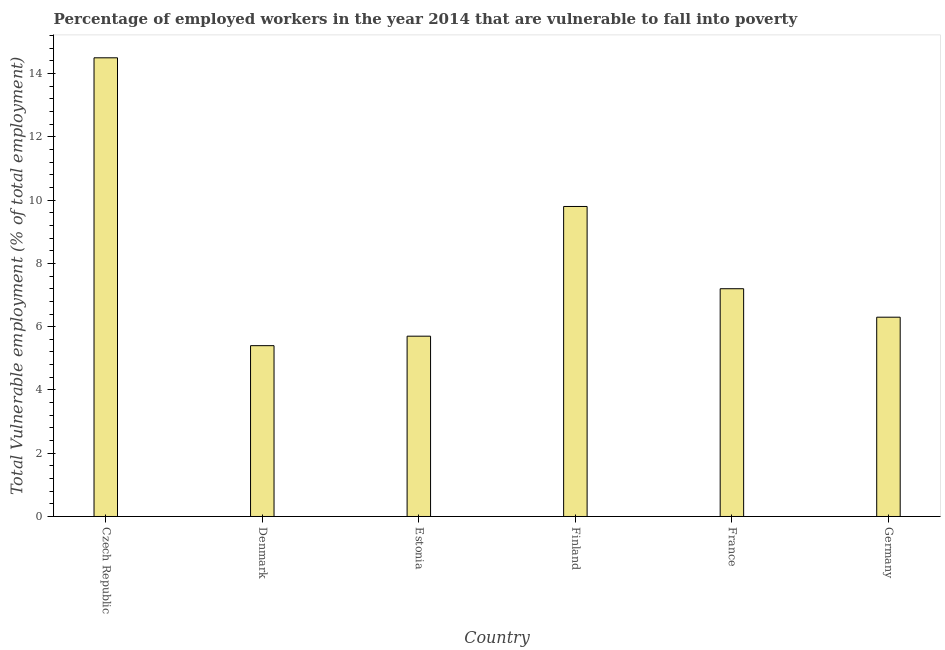Does the graph contain any zero values?
Your answer should be very brief. No. What is the title of the graph?
Your answer should be very brief. Percentage of employed workers in the year 2014 that are vulnerable to fall into poverty. What is the label or title of the X-axis?
Your answer should be compact. Country. What is the label or title of the Y-axis?
Your answer should be compact. Total Vulnerable employment (% of total employment). What is the total vulnerable employment in Denmark?
Keep it short and to the point. 5.4. Across all countries, what is the maximum total vulnerable employment?
Keep it short and to the point. 14.5. Across all countries, what is the minimum total vulnerable employment?
Keep it short and to the point. 5.4. In which country was the total vulnerable employment maximum?
Keep it short and to the point. Czech Republic. What is the sum of the total vulnerable employment?
Your answer should be compact. 48.9. What is the average total vulnerable employment per country?
Offer a very short reply. 8.15. What is the median total vulnerable employment?
Keep it short and to the point. 6.75. In how many countries, is the total vulnerable employment greater than 13.6 %?
Your answer should be very brief. 1. What is the ratio of the total vulnerable employment in Czech Republic to that in Finland?
Your answer should be compact. 1.48. What is the difference between the highest and the lowest total vulnerable employment?
Your answer should be very brief. 9.1. In how many countries, is the total vulnerable employment greater than the average total vulnerable employment taken over all countries?
Provide a short and direct response. 2. How many countries are there in the graph?
Offer a terse response. 6. What is the Total Vulnerable employment (% of total employment) of Denmark?
Offer a very short reply. 5.4. What is the Total Vulnerable employment (% of total employment) of Estonia?
Offer a terse response. 5.7. What is the Total Vulnerable employment (% of total employment) of Finland?
Keep it short and to the point. 9.8. What is the Total Vulnerable employment (% of total employment) of France?
Offer a terse response. 7.2. What is the Total Vulnerable employment (% of total employment) in Germany?
Ensure brevity in your answer.  6.3. What is the difference between the Total Vulnerable employment (% of total employment) in Czech Republic and Finland?
Keep it short and to the point. 4.7. What is the difference between the Total Vulnerable employment (% of total employment) in Czech Republic and Germany?
Your answer should be compact. 8.2. What is the difference between the Total Vulnerable employment (% of total employment) in Denmark and Finland?
Give a very brief answer. -4.4. What is the difference between the Total Vulnerable employment (% of total employment) in Estonia and Finland?
Offer a very short reply. -4.1. What is the difference between the Total Vulnerable employment (% of total employment) in Estonia and Germany?
Offer a terse response. -0.6. What is the difference between the Total Vulnerable employment (% of total employment) in Finland and France?
Your answer should be compact. 2.6. What is the ratio of the Total Vulnerable employment (% of total employment) in Czech Republic to that in Denmark?
Keep it short and to the point. 2.69. What is the ratio of the Total Vulnerable employment (% of total employment) in Czech Republic to that in Estonia?
Make the answer very short. 2.54. What is the ratio of the Total Vulnerable employment (% of total employment) in Czech Republic to that in Finland?
Give a very brief answer. 1.48. What is the ratio of the Total Vulnerable employment (% of total employment) in Czech Republic to that in France?
Your answer should be compact. 2.01. What is the ratio of the Total Vulnerable employment (% of total employment) in Czech Republic to that in Germany?
Provide a succinct answer. 2.3. What is the ratio of the Total Vulnerable employment (% of total employment) in Denmark to that in Estonia?
Your response must be concise. 0.95. What is the ratio of the Total Vulnerable employment (% of total employment) in Denmark to that in Finland?
Your answer should be very brief. 0.55. What is the ratio of the Total Vulnerable employment (% of total employment) in Denmark to that in Germany?
Keep it short and to the point. 0.86. What is the ratio of the Total Vulnerable employment (% of total employment) in Estonia to that in Finland?
Make the answer very short. 0.58. What is the ratio of the Total Vulnerable employment (% of total employment) in Estonia to that in France?
Give a very brief answer. 0.79. What is the ratio of the Total Vulnerable employment (% of total employment) in Estonia to that in Germany?
Offer a very short reply. 0.91. What is the ratio of the Total Vulnerable employment (% of total employment) in Finland to that in France?
Offer a terse response. 1.36. What is the ratio of the Total Vulnerable employment (% of total employment) in Finland to that in Germany?
Keep it short and to the point. 1.56. What is the ratio of the Total Vulnerable employment (% of total employment) in France to that in Germany?
Your response must be concise. 1.14. 